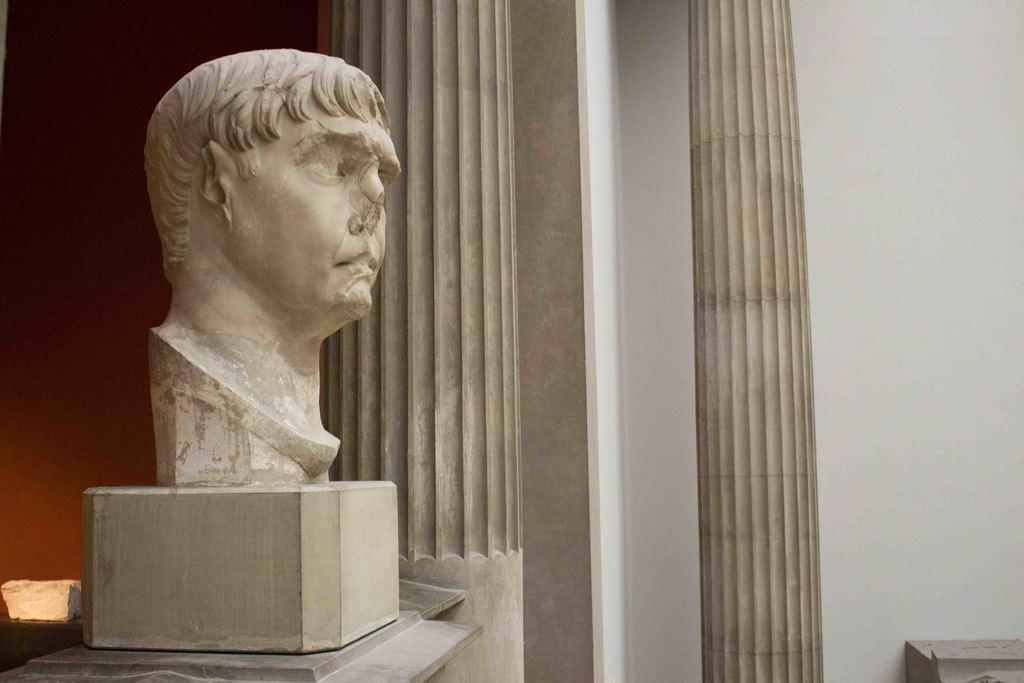What is the main subject of the image? There is a statue in the image. How is the statue positioned in the image? The statue is on a stand. What architectural features can be seen in the image? There are pillars visible in the image. What type of structure is present in the image? There is a wall in the image. Can you tell me how many beetles are crawling on the statue in the image? There are no beetles present on the statue in the image. What type of payment is accepted for the statue in the image? The image does not provide information about payment for the statue. 